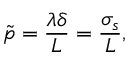<formula> <loc_0><loc_0><loc_500><loc_500>\tilde { p } = \frac { \lambda \delta } { L } = \frac { \sigma _ { s } } { L } ,</formula> 